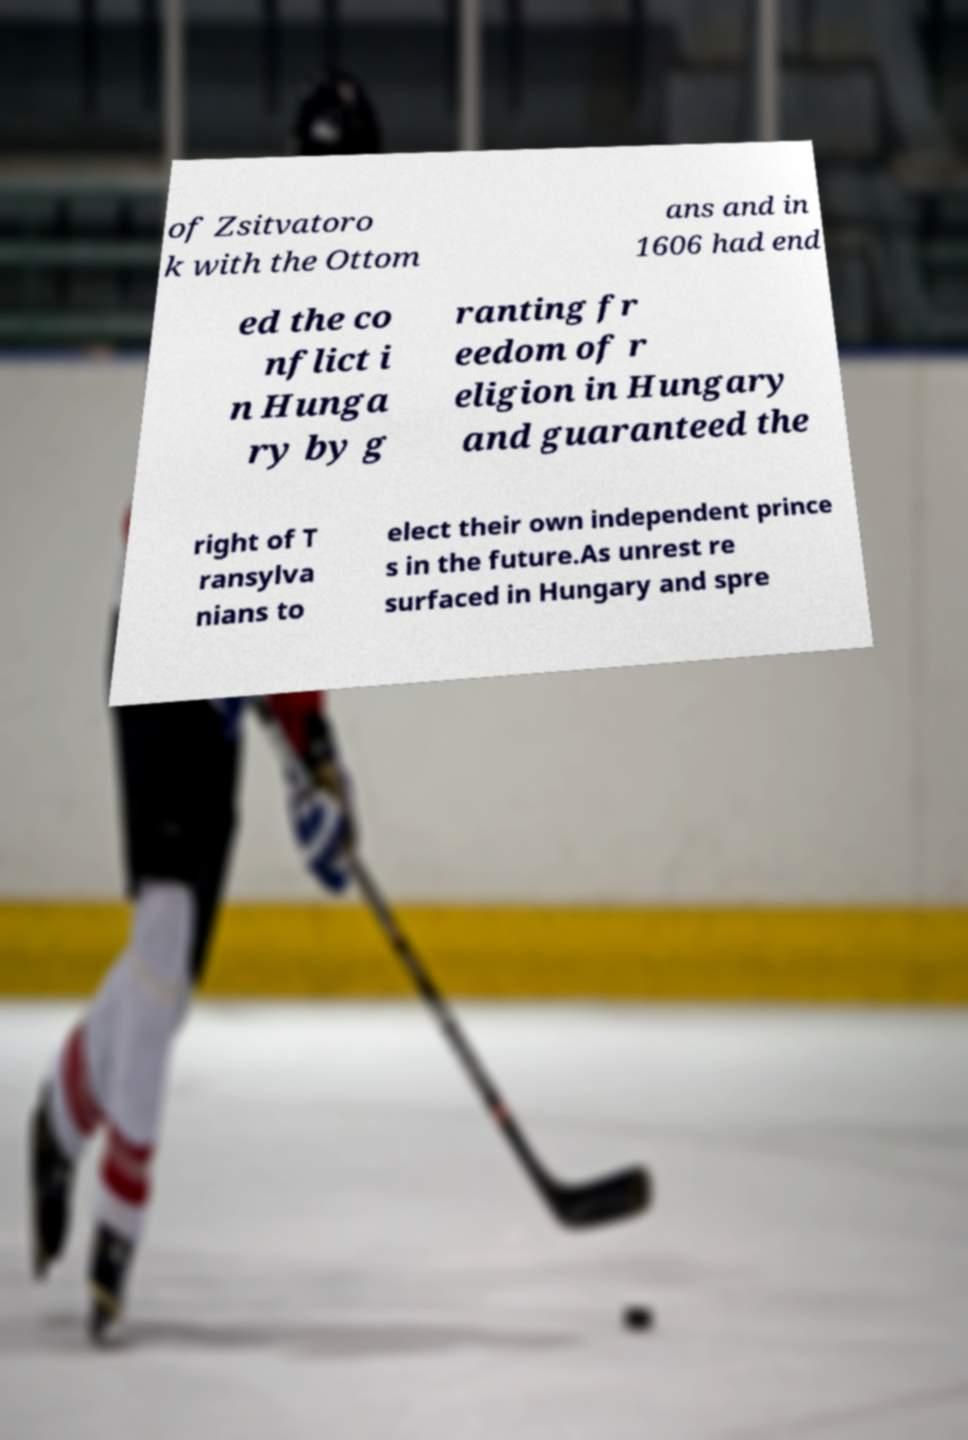What messages or text are displayed in this image? I need them in a readable, typed format. of Zsitvatoro k with the Ottom ans and in 1606 had end ed the co nflict i n Hunga ry by g ranting fr eedom of r eligion in Hungary and guaranteed the right of T ransylva nians to elect their own independent prince s in the future.As unrest re surfaced in Hungary and spre 